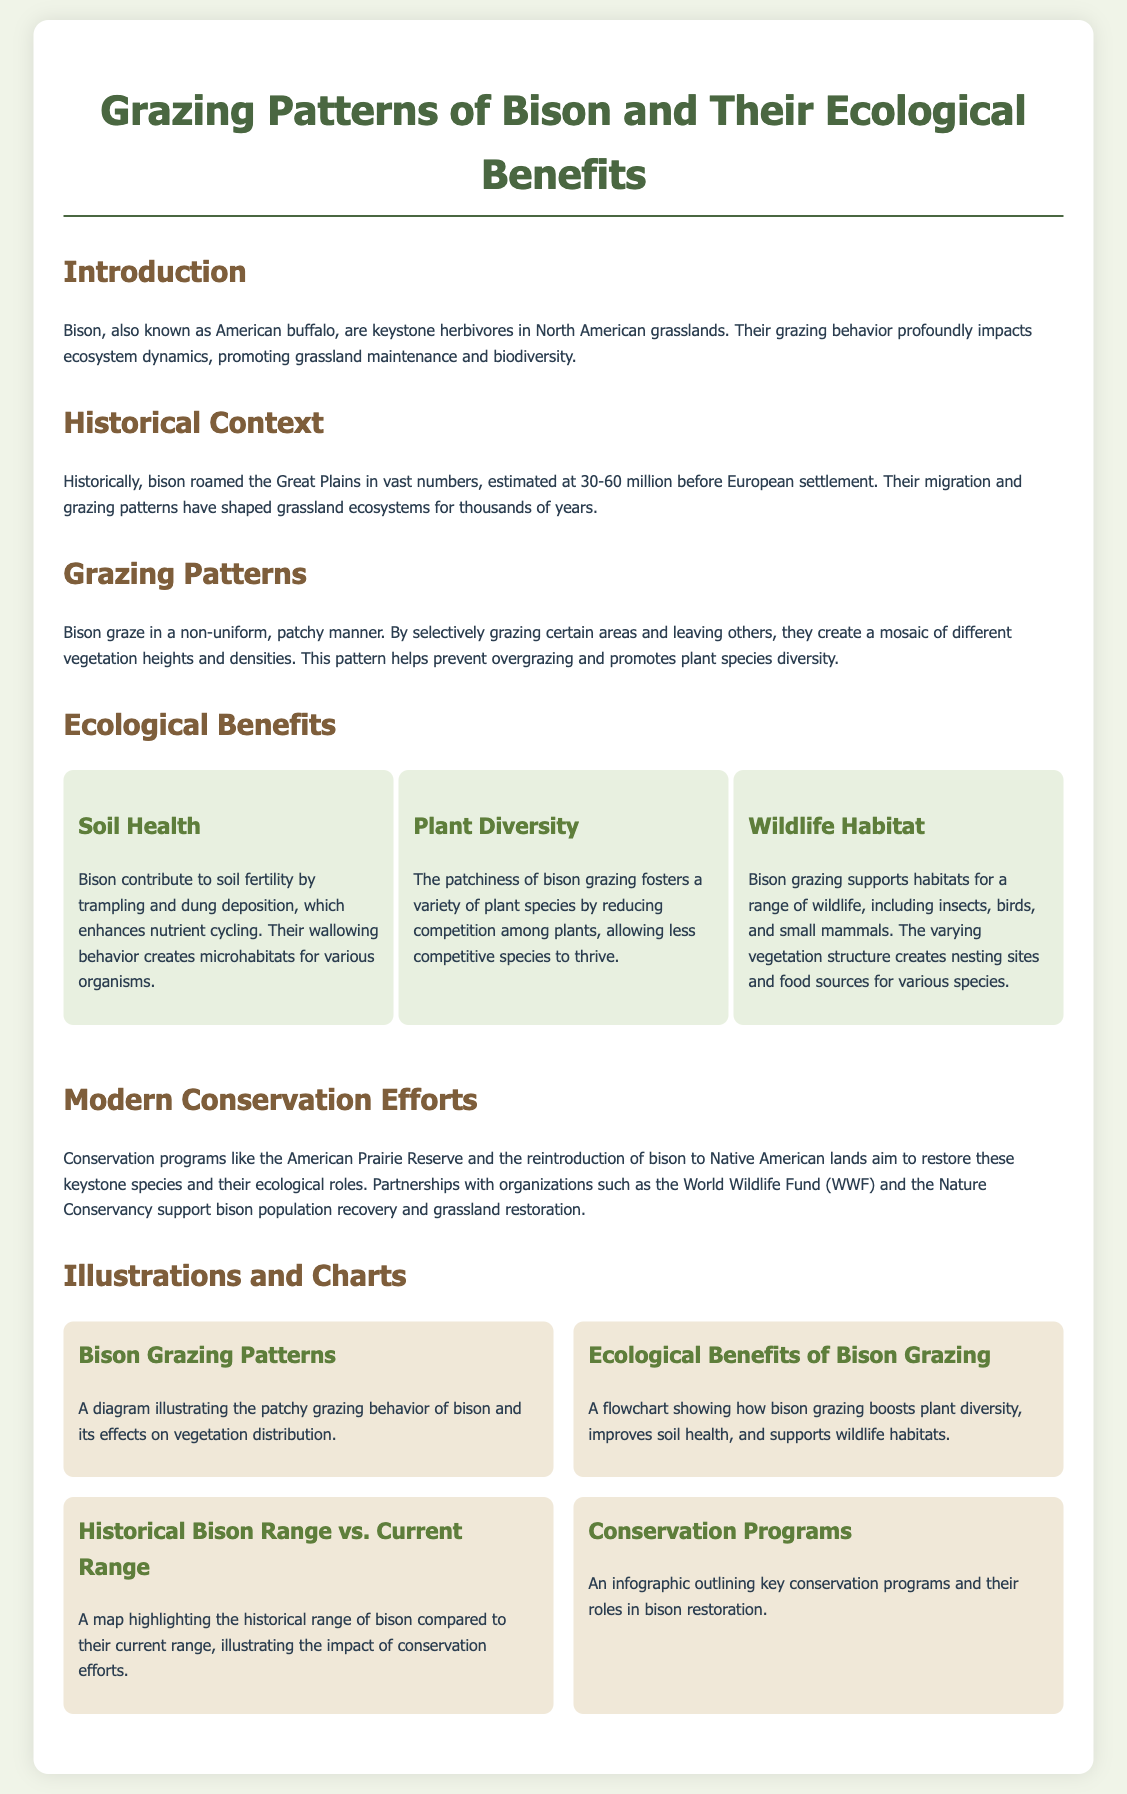What are bison also known as? The document states that bison are also known as American buffalo.
Answer: American buffalo What estimated number of bison existed before European settlement? The document mentions that historical bison numbers are estimated at 30-60 million before European settlement.
Answer: 30-60 million What grazing pattern do bison exhibit? The document describes bison grazing as non-uniform and patchy.
Answer: Patchy What is one ecological benefit of bison grazing mentioned in the document? The document lists benefits such as soil health, plant diversity, and wildlife habitat; one of these is soil health.
Answer: Soil health Which conservation program is mentioned in relation to bison? The document refers to the American Prairie Reserve as a conservation program aimed at bison restoration.
Answer: American Prairie Reserve Why do bison create a mosaic of different vegetation heights and densities? The document explains that this occurs because bison graze selectively and leave other areas ungrazed, preventing overgrazing.
Answer: To prevent overgrazing What type of diagram illustrates the patchy grazing behavior of bison? The document refers to a diagram demonstrating bison grazing patterns.
Answer: Bison Grazing Patterns What historical aspect does the document compare to the current range of bison? The document compares the historical range of bison to their current range, highlighting the impact of conservation efforts.
Answer: Historical range vs. Current range 